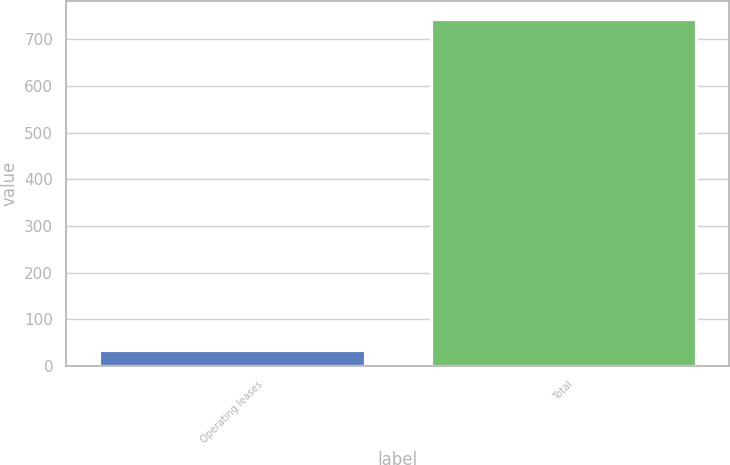Convert chart. <chart><loc_0><loc_0><loc_500><loc_500><bar_chart><fcel>Operating leases<fcel>Total<nl><fcel>35<fcel>744<nl></chart> 